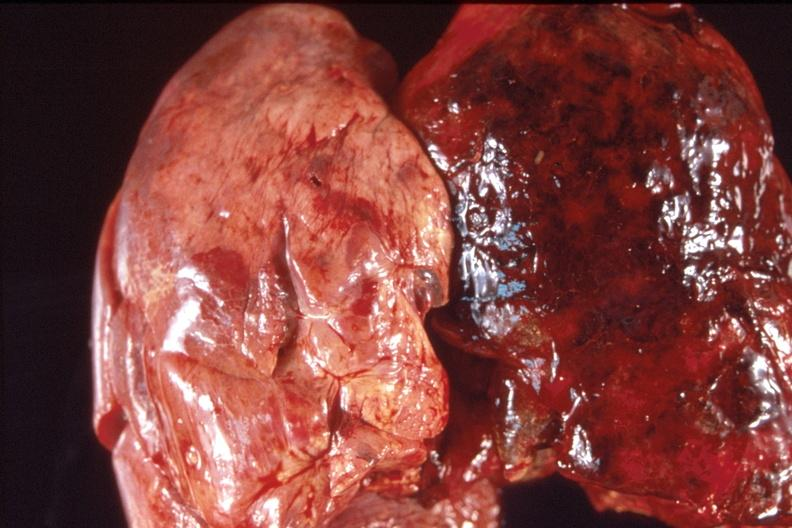what does this image show?
Answer the question using a single word or phrase. Lung 